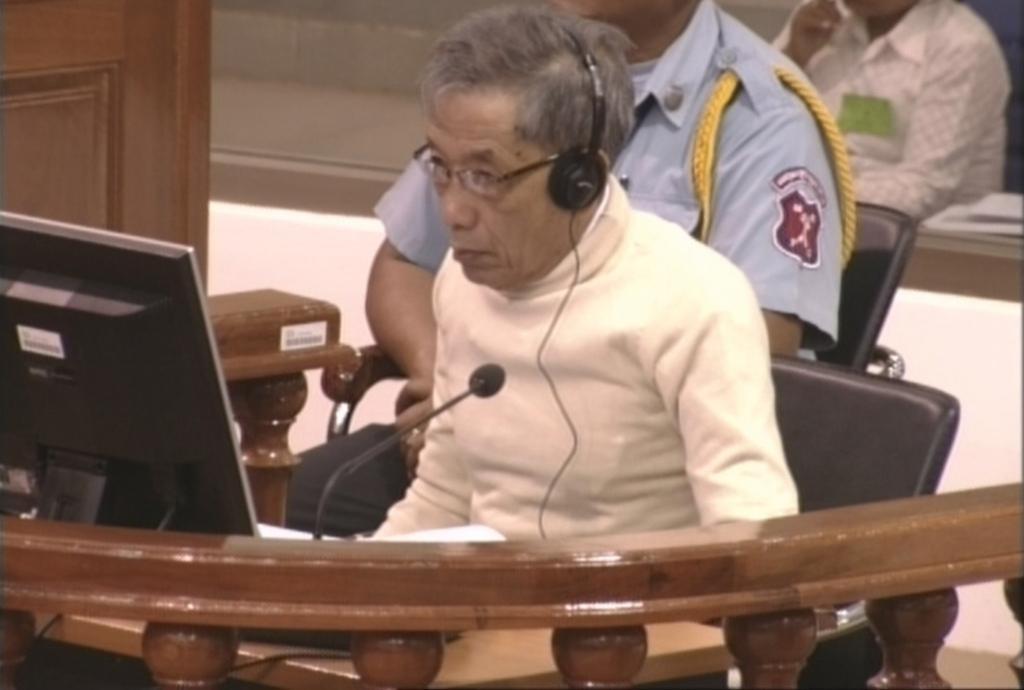Please provide a concise description of this image. In this image I can see a person wearing cream colored dress is sitting on the black colored chair. I can see a microphone, a monitor, a desk and the railing in front of him. In the background I can see few other persons sitting and the brown colored object. 